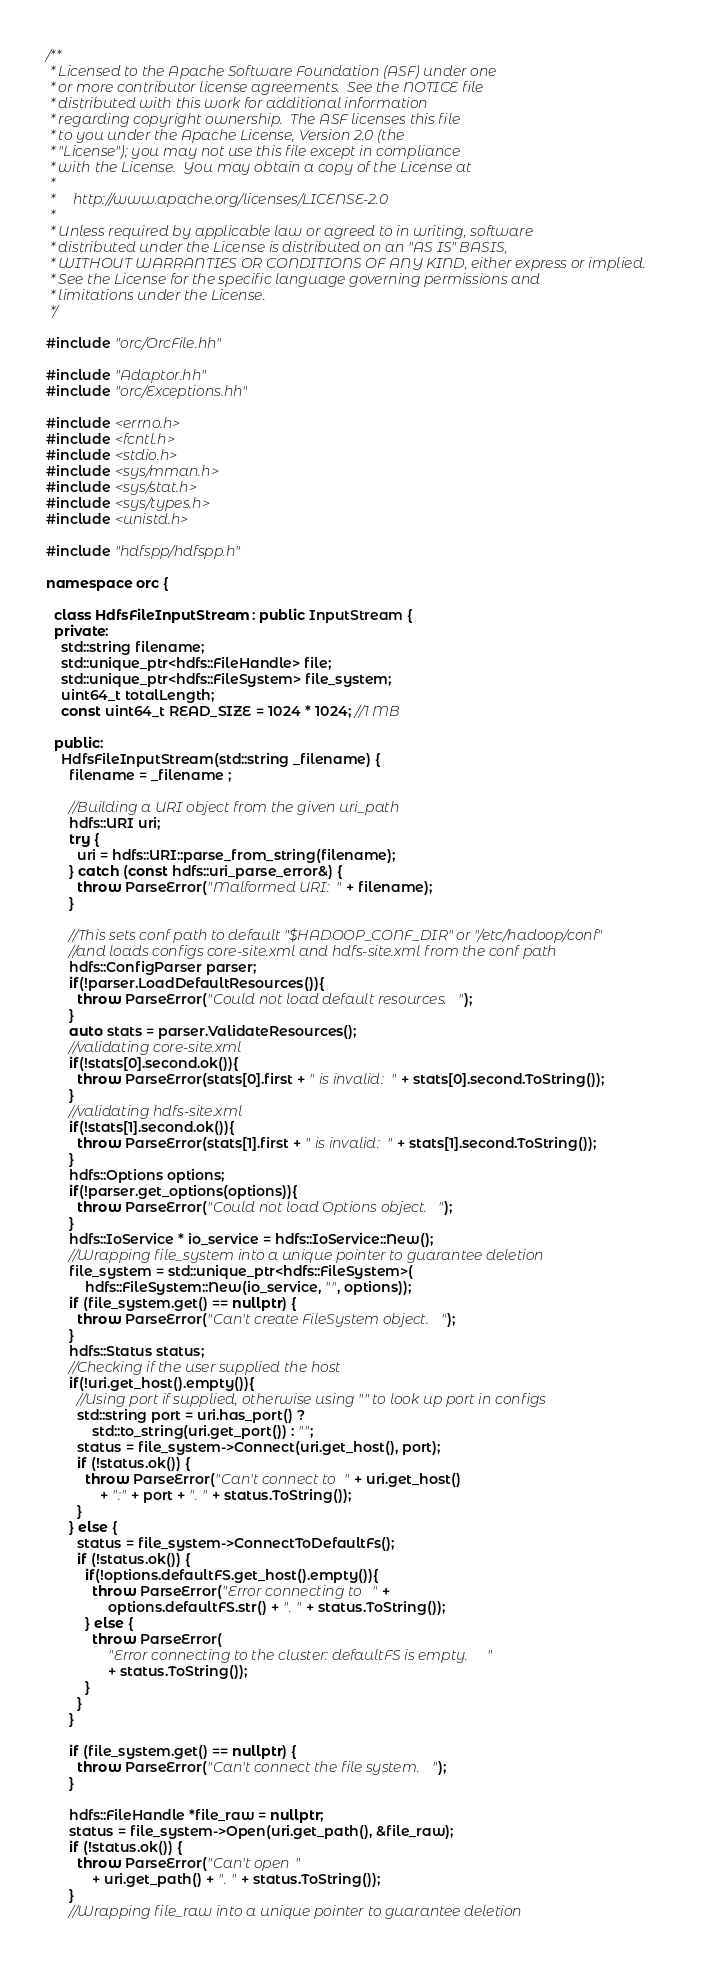<code> <loc_0><loc_0><loc_500><loc_500><_C++_>/**
 * Licensed to the Apache Software Foundation (ASF) under one
 * or more contributor license agreements.  See the NOTICE file
 * distributed with this work for additional information
 * regarding copyright ownership.  The ASF licenses this file
 * to you under the Apache License, Version 2.0 (the
 * "License"); you may not use this file except in compliance
 * with the License.  You may obtain a copy of the License at
 *
 *     http://www.apache.org/licenses/LICENSE-2.0
 *
 * Unless required by applicable law or agreed to in writing, software
 * distributed under the License is distributed on an "AS IS" BASIS,
 * WITHOUT WARRANTIES OR CONDITIONS OF ANY KIND, either express or implied.
 * See the License for the specific language governing permissions and
 * limitations under the License.
 */

#include "orc/OrcFile.hh"

#include "Adaptor.hh"
#include "orc/Exceptions.hh"

#include <errno.h>
#include <fcntl.h>
#include <stdio.h>
#include <sys/mman.h>
#include <sys/stat.h>
#include <sys/types.h>
#include <unistd.h>

#include "hdfspp/hdfspp.h"

namespace orc {

  class HdfsFileInputStream : public InputStream {
  private:
    std::string filename;
    std::unique_ptr<hdfs::FileHandle> file;
    std::unique_ptr<hdfs::FileSystem> file_system;
    uint64_t totalLength;
    const uint64_t READ_SIZE = 1024 * 1024; //1 MB

  public:
    HdfsFileInputStream(std::string _filename) {
      filename = _filename ;

      //Building a URI object from the given uri_path
      hdfs::URI uri;
      try {
        uri = hdfs::URI::parse_from_string(filename);
      } catch (const hdfs::uri_parse_error&) {
        throw ParseError("Malformed URI: " + filename);
      }

      //This sets conf path to default "$HADOOP_CONF_DIR" or "/etc/hadoop/conf"
      //and loads configs core-site.xml and hdfs-site.xml from the conf path
      hdfs::ConfigParser parser;
      if(!parser.LoadDefaultResources()){
        throw ParseError("Could not load default resources. ");
      }
      auto stats = parser.ValidateResources();
      //validating core-site.xml
      if(!stats[0].second.ok()){
        throw ParseError(stats[0].first + " is invalid: " + stats[0].second.ToString());
      }
      //validating hdfs-site.xml
      if(!stats[1].second.ok()){
        throw ParseError(stats[1].first + " is invalid: " + stats[1].second.ToString());
      }
      hdfs::Options options;
      if(!parser.get_options(options)){
        throw ParseError("Could not load Options object. ");
      }
      hdfs::IoService * io_service = hdfs::IoService::New();
      //Wrapping file_system into a unique pointer to guarantee deletion
      file_system = std::unique_ptr<hdfs::FileSystem>(
          hdfs::FileSystem::New(io_service, "", options));
      if (file_system.get() == nullptr) {
        throw ParseError("Can't create FileSystem object. ");
      }
      hdfs::Status status;
      //Checking if the user supplied the host
      if(!uri.get_host().empty()){
        //Using port if supplied, otherwise using "" to look up port in configs
        std::string port = uri.has_port() ?
            std::to_string(uri.get_port()) : "";
        status = file_system->Connect(uri.get_host(), port);
        if (!status.ok()) {
          throw ParseError("Can't connect to " + uri.get_host()
              + ":" + port + ". " + status.ToString());
        }
      } else {
        status = file_system->ConnectToDefaultFs();
        if (!status.ok()) {
          if(!options.defaultFS.get_host().empty()){
            throw ParseError("Error connecting to " +
                options.defaultFS.str() + ". " + status.ToString());
          } else {
            throw ParseError(
                "Error connecting to the cluster: defaultFS is empty. "
                + status.ToString());
          }
        }
      }

      if (file_system.get() == nullptr) {
        throw ParseError("Can't connect the file system. ");
      }

      hdfs::FileHandle *file_raw = nullptr;
      status = file_system->Open(uri.get_path(), &file_raw);
      if (!status.ok()) {
        throw ParseError("Can't open "
            + uri.get_path() + ". " + status.ToString());
      }
      //Wrapping file_raw into a unique pointer to guarantee deletion</code> 